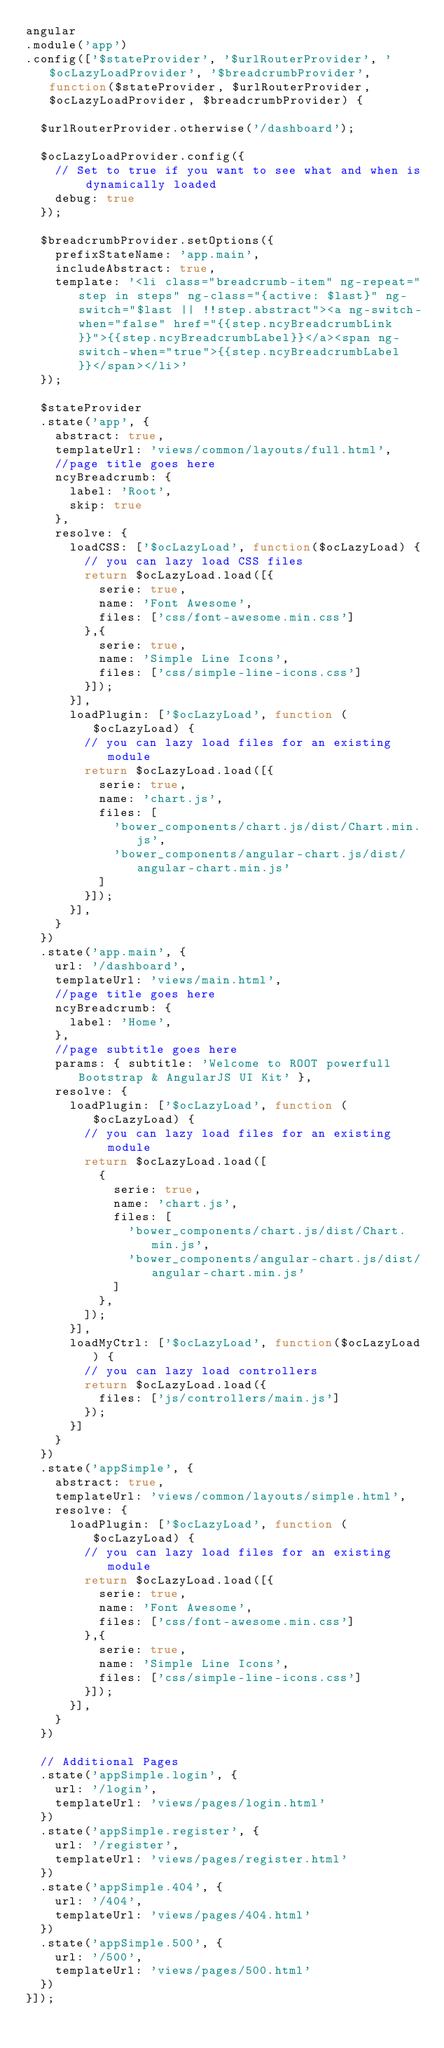<code> <loc_0><loc_0><loc_500><loc_500><_JavaScript_>angular
.module('app')
.config(['$stateProvider', '$urlRouterProvider', '$ocLazyLoadProvider', '$breadcrumbProvider', function($stateProvider, $urlRouterProvider, $ocLazyLoadProvider, $breadcrumbProvider) {

  $urlRouterProvider.otherwise('/dashboard');

  $ocLazyLoadProvider.config({
    // Set to true if you want to see what and when is dynamically loaded
    debug: true
  });

  $breadcrumbProvider.setOptions({
    prefixStateName: 'app.main',
    includeAbstract: true,
    template: '<li class="breadcrumb-item" ng-repeat="step in steps" ng-class="{active: $last}" ng-switch="$last || !!step.abstract"><a ng-switch-when="false" href="{{step.ncyBreadcrumbLink}}">{{step.ncyBreadcrumbLabel}}</a><span ng-switch-when="true">{{step.ncyBreadcrumbLabel}}</span></li>'
  });

  $stateProvider
  .state('app', {
    abstract: true,
    templateUrl: 'views/common/layouts/full.html',
    //page title goes here
    ncyBreadcrumb: {
      label: 'Root',
      skip: true
    },
    resolve: {
      loadCSS: ['$ocLazyLoad', function($ocLazyLoad) {
        // you can lazy load CSS files
        return $ocLazyLoad.load([{
          serie: true,
          name: 'Font Awesome',
          files: ['css/font-awesome.min.css']
        },{
          serie: true,
          name: 'Simple Line Icons',
          files: ['css/simple-line-icons.css']
        }]);
      }],
      loadPlugin: ['$ocLazyLoad', function ($ocLazyLoad) {
        // you can lazy load files for an existing module
        return $ocLazyLoad.load([{
          serie: true,
          name: 'chart.js',
          files: [
            'bower_components/chart.js/dist/Chart.min.js',
            'bower_components/angular-chart.js/dist/angular-chart.min.js'
          ]
        }]);
      }],
    }
  })
  .state('app.main', {
    url: '/dashboard',
    templateUrl: 'views/main.html',
    //page title goes here
    ncyBreadcrumb: {
      label: 'Home',
    },
    //page subtitle goes here
    params: { subtitle: 'Welcome to ROOT powerfull Bootstrap & AngularJS UI Kit' },
    resolve: {
      loadPlugin: ['$ocLazyLoad', function ($ocLazyLoad) {
        // you can lazy load files for an existing module
        return $ocLazyLoad.load([
          {
            serie: true,
            name: 'chart.js',
            files: [
              'bower_components/chart.js/dist/Chart.min.js',
              'bower_components/angular-chart.js/dist/angular-chart.min.js'
            ]
          },
        ]);
      }],
      loadMyCtrl: ['$ocLazyLoad', function($ocLazyLoad) {
        // you can lazy load controllers
        return $ocLazyLoad.load({
          files: ['js/controllers/main.js']
        });
      }]
    }
  })
  .state('appSimple', {
    abstract: true,
    templateUrl: 'views/common/layouts/simple.html',
    resolve: {
      loadPlugin: ['$ocLazyLoad', function ($ocLazyLoad) {
        // you can lazy load files for an existing module
        return $ocLazyLoad.load([{
          serie: true,
          name: 'Font Awesome',
          files: ['css/font-awesome.min.css']
        },{
          serie: true,
          name: 'Simple Line Icons',
          files: ['css/simple-line-icons.css']
        }]);
      }],
    }
  })

  // Additional Pages
  .state('appSimple.login', {
    url: '/login',
    templateUrl: 'views/pages/login.html'
  })
  .state('appSimple.register', {
    url: '/register',
    templateUrl: 'views/pages/register.html'
  })
  .state('appSimple.404', {
    url: '/404',
    templateUrl: 'views/pages/404.html'
  })
  .state('appSimple.500', {
    url: '/500',
    templateUrl: 'views/pages/500.html'
  })
}]);
</code> 